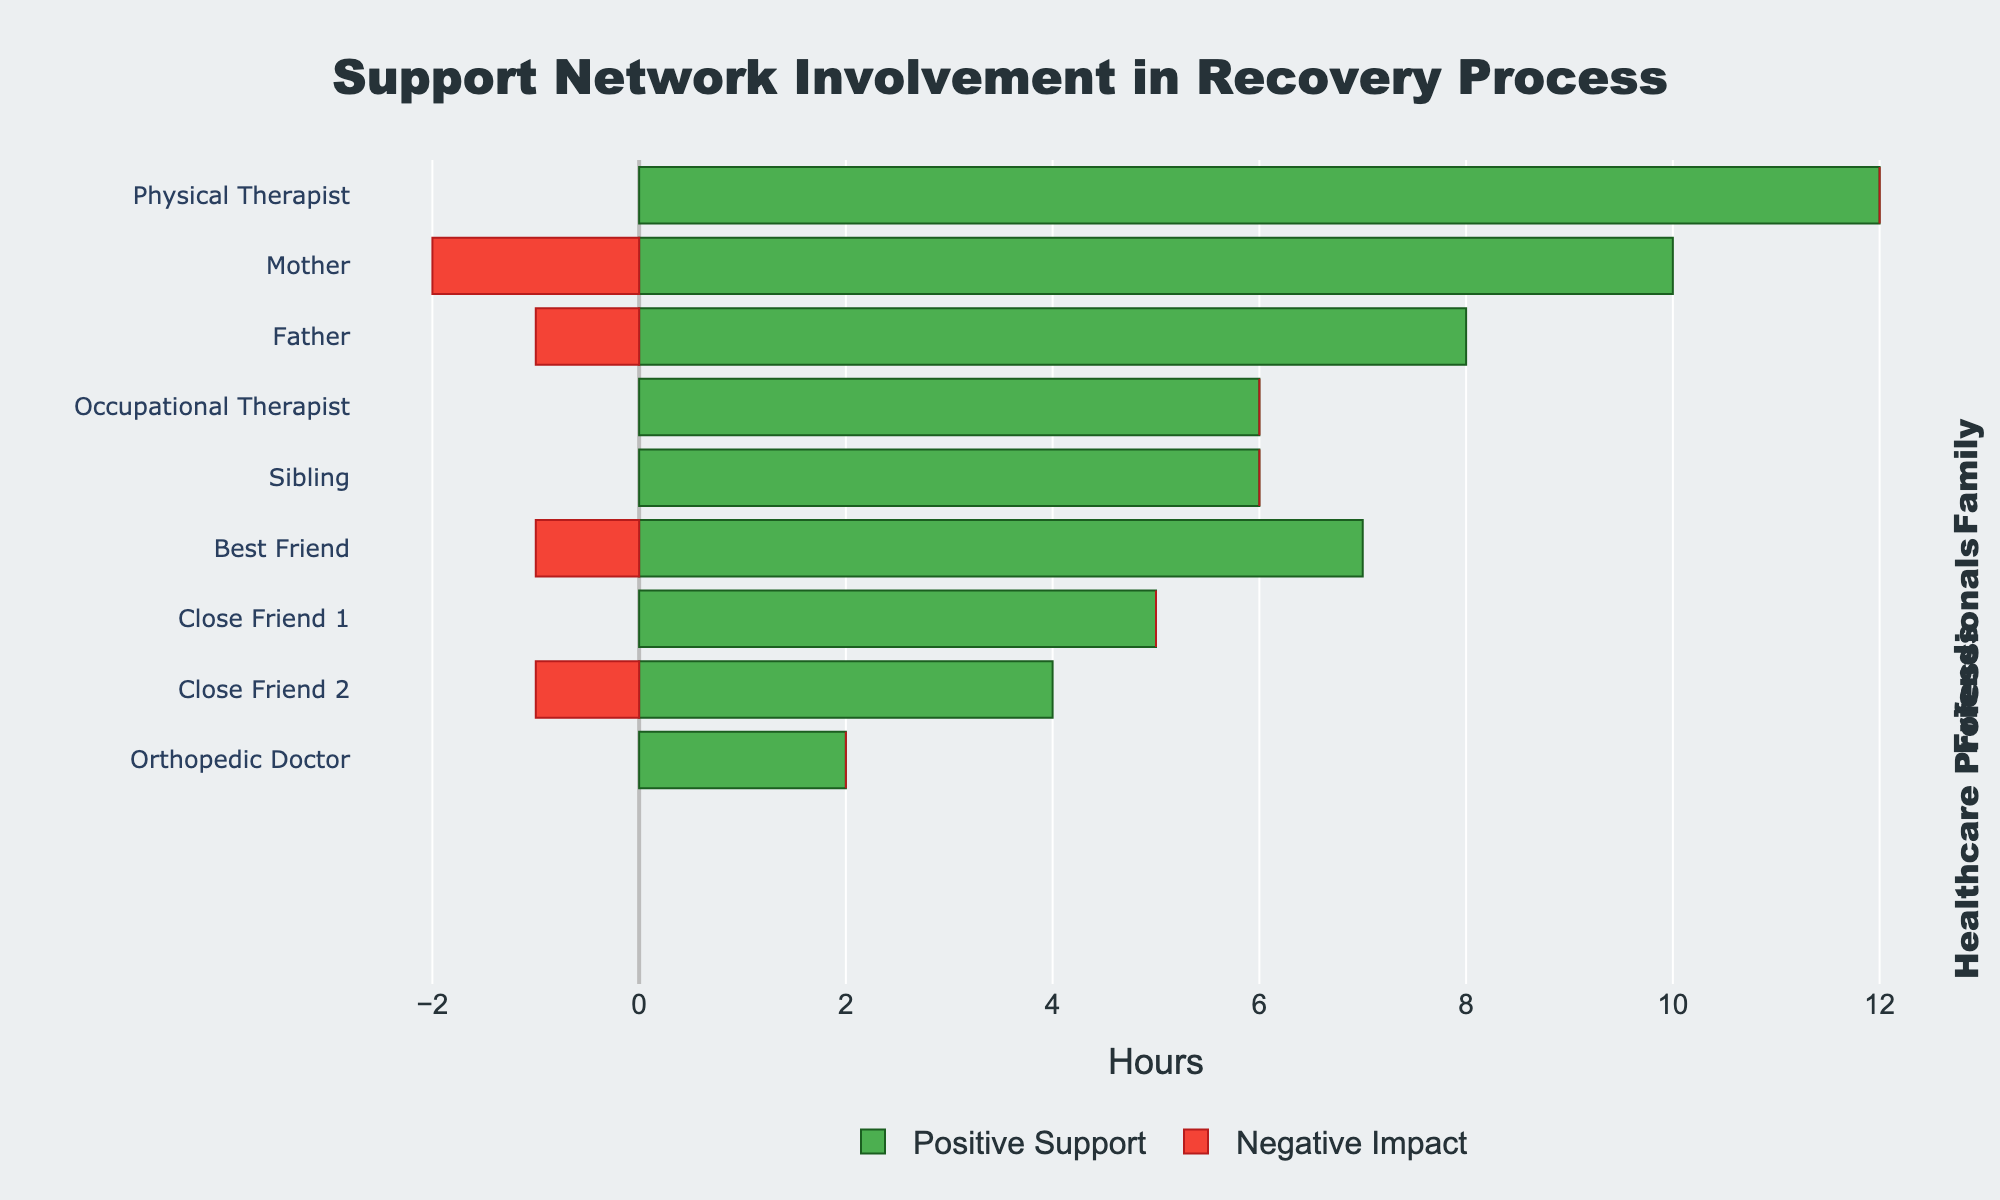Which entity provided the most positive support hours? The length of the green bar representing positive support hours is longest for the Physical Therapist.
Answer: Physical Therapist Which family member provided the least total hours of support? The total hours (positive + negative) must be calculated and compared for each family member. Sibling has the smallest sum with 6 (positive support) + 0 (negative impact) = 6 hours.
Answer: Sibling How many more hours of positive support did the Physical Therapist provide compared to the Best Friend? Calculate the difference between the Physical Therapist's positive support hours (12) and the Best Friend's positive support hours (7). 12 - 7 = 5.
Answer: 5 What is the combined negative impact hours from all the friends? Sum up the negative impact hours for Best Friend (1), Close Friend 1 (0), and Close Friend 2 (1). 1 + 0 + 1 = 2.
Answer: 2 Which healthcare professional provided the least amount of total support (positive plus negative)? Calculate the total support hours for each healthcare professional. The Orthopedic Doctor has the fewest total with 2 (positive support) + 0 (negative impact) = 2 hours.
Answer: Orthopedic Doctor Which category (Family, Friends, Healthcare Professionals) has the highest average positive support hours per entity? Calculate the average for each category: 
- Family: (10 + 8 + 6)/3 = 8 
- Friends: (7 + 5 + 4)/3 ≈ 5.33 
- Healthcare Professionals: (12 + 2 + 6)/3 = 6.67
The largest is Family with an average of 8.
Answer: Family How much more total support did the Physical Therapist provide compared to the Mother? Add the positive and negative hours for both: Physical Therapist (12 + 0 = 12) and Mother (10 + 2 = 12). No difference as both provide equal total hours.
Answer: 0 Among the entities, which has no negative impact hours? Examine the red bars (negative impact) for each entity to identify which do not have a corresponding segment. Sibling, Close Friend 1, Physical Therapist, Orthopedic Doctor, and Occupational Therapist have no negative impact hours.
Answer: Sibling, Close Friend 1, Physical Therapist, Orthopedic Doctor, Occupational Therapist 